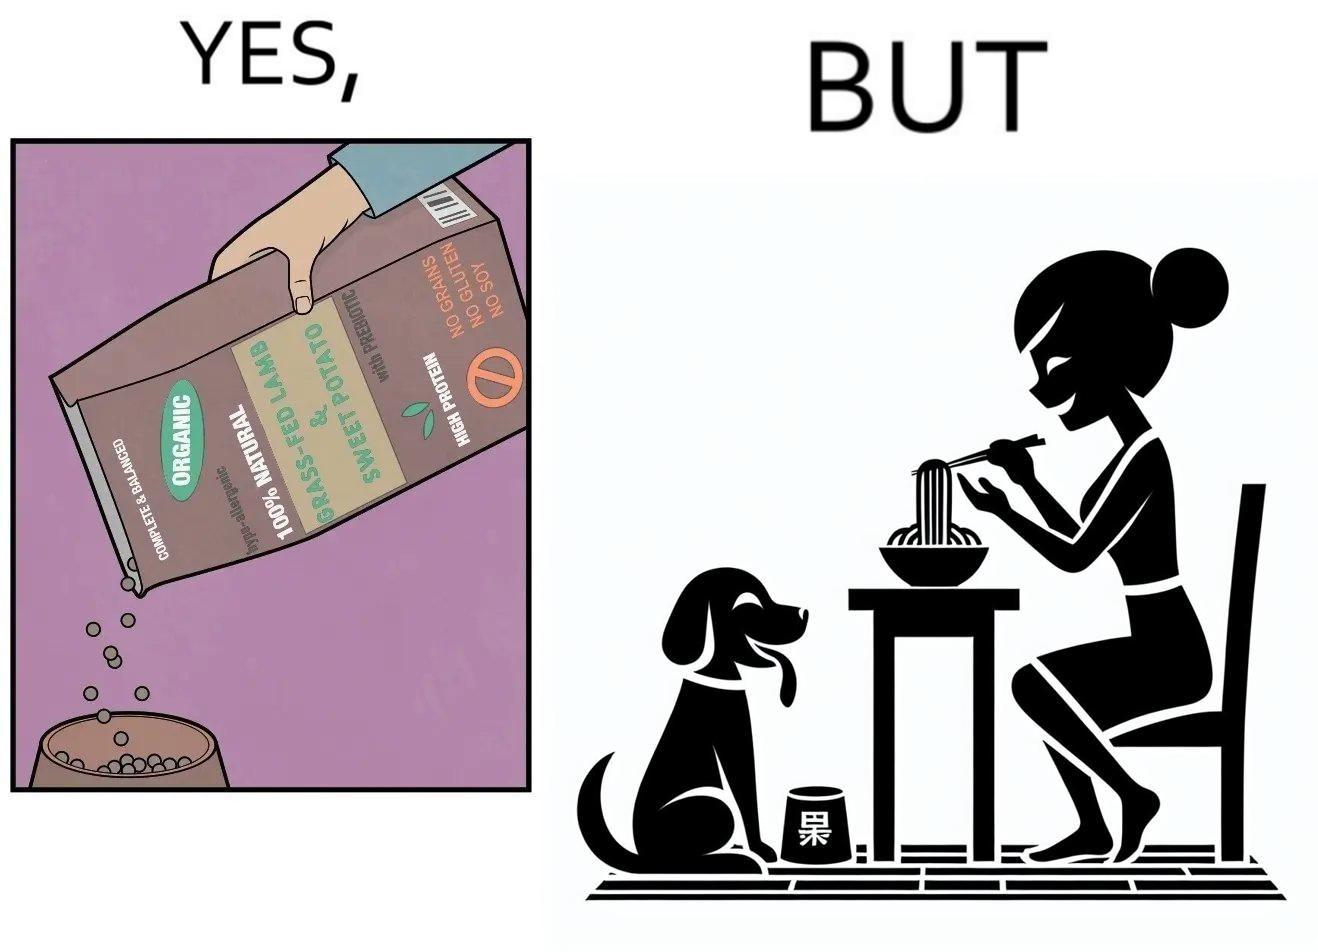Compare the left and right sides of this image. In the left part of the image: The image shows food grains being poured into a bowl from the packet. The packet says "Complete & Balanced", "Organic", "100% Natural", "Grass Fed Lamb & Sweet Potato" , "With Prebiotic", "High Protein", "No grains", "No Gluten" and "No Soy". In the right part of the image: The image shows a dog eating food from its bowl on the floor and a woman eating noodles from a cup on the table. 